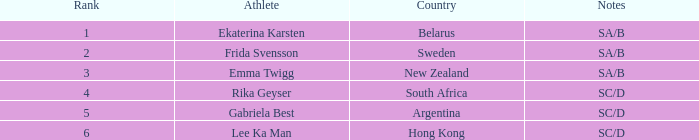What is the race duration for emma twigg? 7:34.24. 